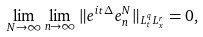Convert formula to latex. <formula><loc_0><loc_0><loc_500><loc_500>\lim _ { N \to \infty } \lim _ { n \to \infty } \| e ^ { i t \Delta } e _ { n } ^ { N } \| _ { L _ { t } ^ { q } L ^ { r } _ { x } } = 0 ,</formula> 